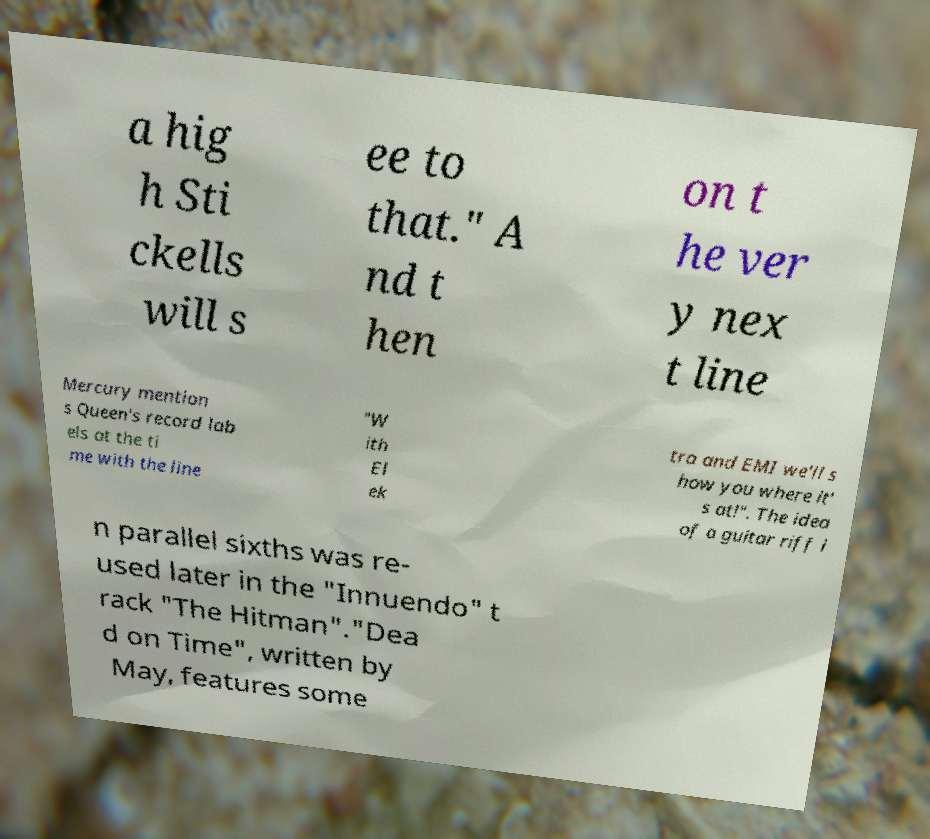Could you assist in decoding the text presented in this image and type it out clearly? a hig h Sti ckells will s ee to that." A nd t hen on t he ver y nex t line Mercury mention s Queen's record lab els at the ti me with the line "W ith El ek tra and EMI we'll s how you where it' s at!". The idea of a guitar riff i n parallel sixths was re- used later in the "Innuendo" t rack "The Hitman"."Dea d on Time", written by May, features some 